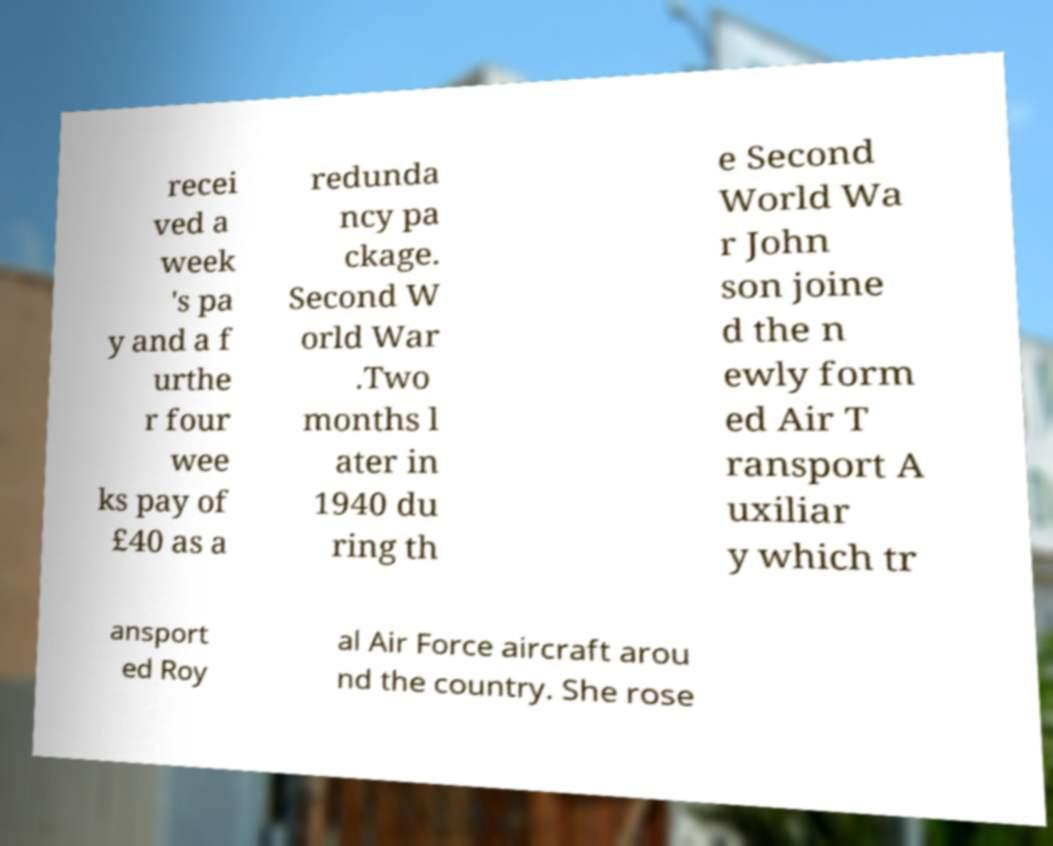Could you extract and type out the text from this image? recei ved a week 's pa y and a f urthe r four wee ks pay of £40 as a redunda ncy pa ckage. Second W orld War .Two months l ater in 1940 du ring th e Second World Wa r John son joine d the n ewly form ed Air T ransport A uxiliar y which tr ansport ed Roy al Air Force aircraft arou nd the country. She rose 